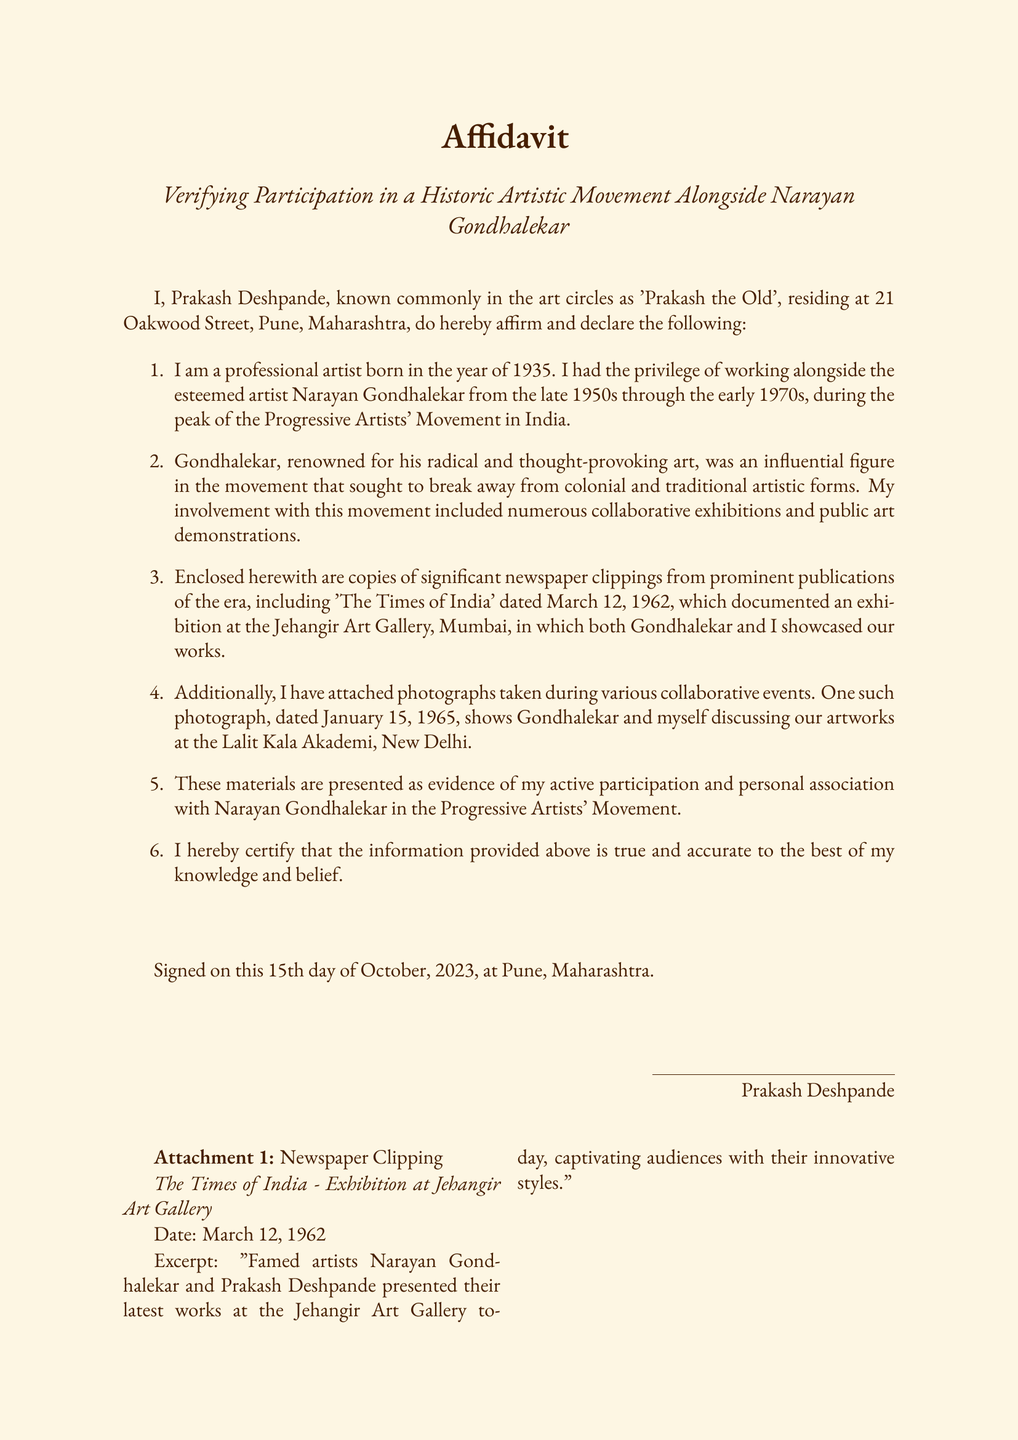What is the full name of the affiant? The affiant's full name is Prakash Deshpande.
Answer: Prakash Deshpande In which year was the affiant born? The document states that the affiant was born in 1935.
Answer: 1935 What is the title of the event documented in the newspaper clipping? The title in the newspaper clipping refers to an exhibition at the Jehangir Art Gallery.
Answer: Exhibition at Jehangir Art Gallery What date is mentioned for the newspaper clipping? The newspaper clipping is dated March 12, 1962.
Answer: March 12, 1962 What is the date of the photograph mentioned in the affidavit? The photograph is dated January 15, 1965.
Answer: January 15, 1965 What was the location of the discussion depicted in the photograph? The discussion took place at the Lalit Kala Akademi, New Delhi.
Answer: Lalit Kala Akademi, New Delhi What significant artistic movement does the affidavit discuss? The document refers to the Progressive Artists' Movement.
Answer: Progressive Artists' Movement Which artist is noted as an influential figure alongside the affiant? The influential figure mentioned is Narayan Gondhalekar.
Answer: Narayan Gondhalekar On what date was the affidavit signed? The affidavit was signed on October 15, 2023.
Answer: October 15, 2023 